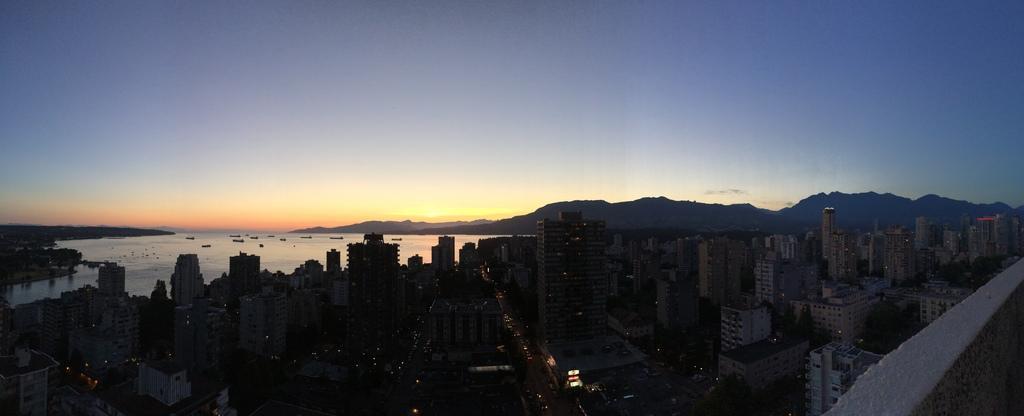Please provide a concise description of this image. This image is taken during the evening. In this image we can see many buildings, hills and also the boats on the surface of the water. We can also see the sky. There are vehicles passing on the road. 